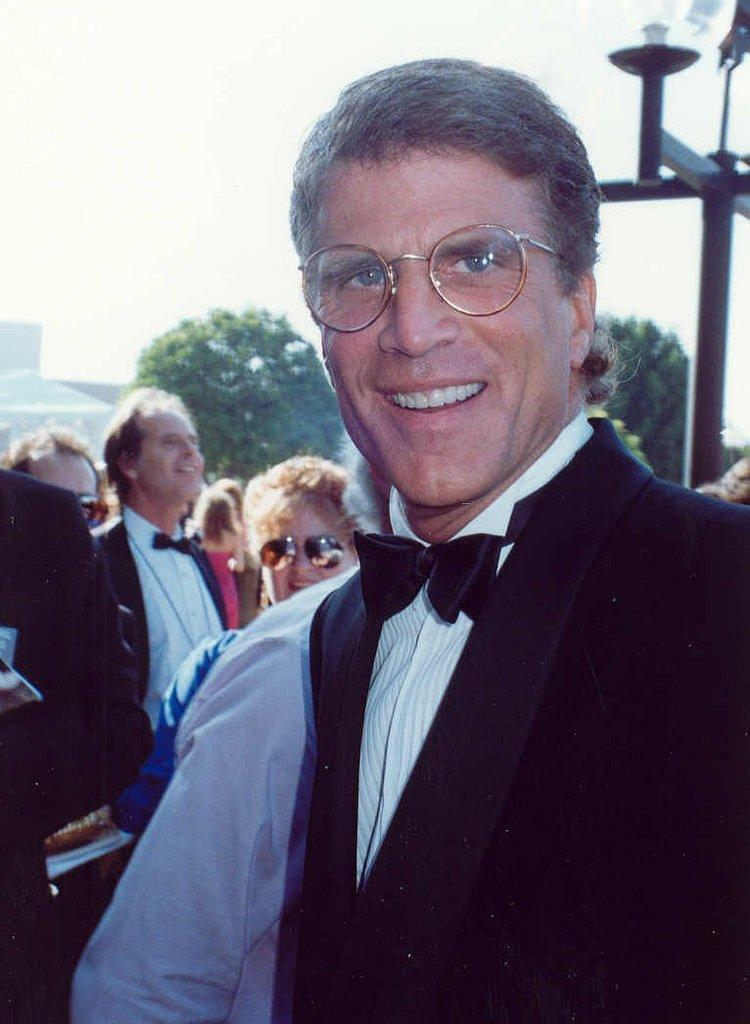Who or what can be seen in the image? There are people in the image. What type of natural elements are present in the image? There are trees in the image. What type of man-made structure is visible in the image? There is a building in the image. Can you describe any artificial light sources in the image? There is a light attached to a pole in the image. What type of straw is being used by the people in the image? There is no straw visible in the image. Can you see a plane flying in the sky in the image? There is no plane visible in the image. Is there a star visible in the image? There is no star visible in the image. 